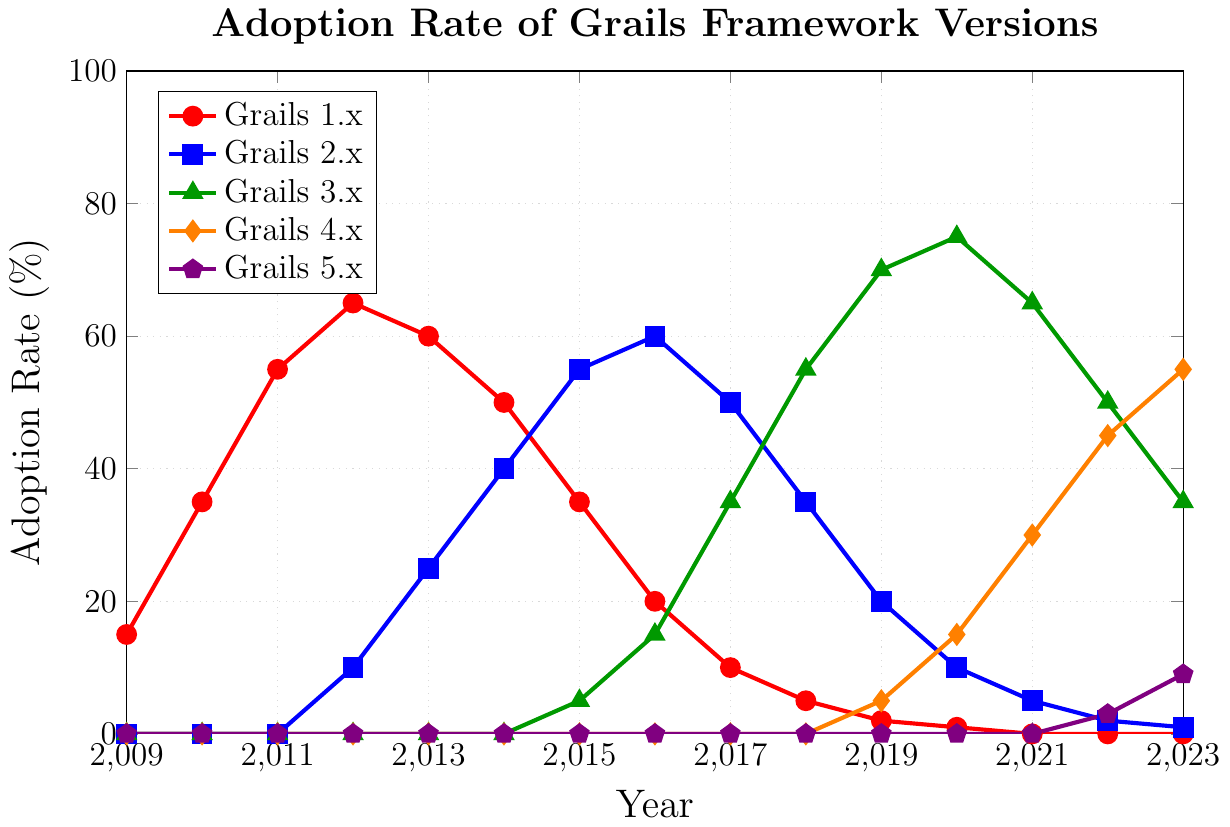How did the adoption rate of Grails 1.x change from 2011 to 2017? To determine the change, subtract the adoption rate in 2017 from the adoption rate in 2011. In 2011, the rate was 55%, and in 2017, it was 10%. The change is 55% - 10% = 45%.
Answer: 45% Which version had the highest adoption rate in 2015? To find the version with the highest adoption rate in 2015, compare the adoption rates for all versions in that year. Grails 1.x had 35%, Grails 2.x had 55%, and Grails 3.x had 5%. Grails 2.x has the highest rate.
Answer: Grails 2.x By how much did the adoption rate of Grails 3.x increase from 2015 to 2019? Calculate the difference in adoption rates for Grails 3.x between 2015 and 2019. In 2015, it was 5%, and in 2019, it was 70%. The increase is 70% - 5% = 65%.
Answer: 65% Which version showed consistent growth between 2018 and 2023? Look for a version whose adoption rate increases every year from 2018 to 2023. Grails 4.x shows an increase from 0% in 2018 to 55% in 2023.
Answer: Grails 4.x In 2017, which versions had greater adoption rates than Grails 1.x? Grails 1.x had a 10% adoption rate in 2017. Compare this with other versions: Grails 2.x had 50%, Grails 3.x had 35%, and Grails 4.x had 0%. Both Grails 2.x and 3.x had higher rates.
Answer: Grails 2.x and Grails 3.x What was the trend in the adoption rate for Grails 2.x from 2016 to 2020? Examine the adoption rates of Grails 2.x over the years 2016 (60%), 2017 (50%), 2018 (35%), 2019 (20%), and 2020 (10%). The trend is a consistent decrease.
Answer: Decreasing In which year did Grails 3.x surpass Grails 2.x in adoption rate? Identify when Grails 3.x first had a higher percentage than Grails 2.x. Grails 3.x surpassed Grails 2.x in 2017 (35% vs. 50%) and maintained a higher rate thereafter. The surpassing happened in 2017.
Answer: 2017 What is the sum of the adoption rates for all versions in 2022? Add the adoption rates for all versions in 2022: Grails 1.x (0%), Grails 2.x (2%), Grails 3.x (50%), Grails 4.x (45%), and Grails 5.x (3%). The sum is 0% + 2% + 50% + 45% + 3% = 100%.
Answer: 100% In which years did Grails 1.x have an adoption rate of zero? Locate the years on the graph where Grails 1.x has an adoption rate of 0%. These years are 2021, 2022, and 2023.
Answer: 2021, 2022, 2023 